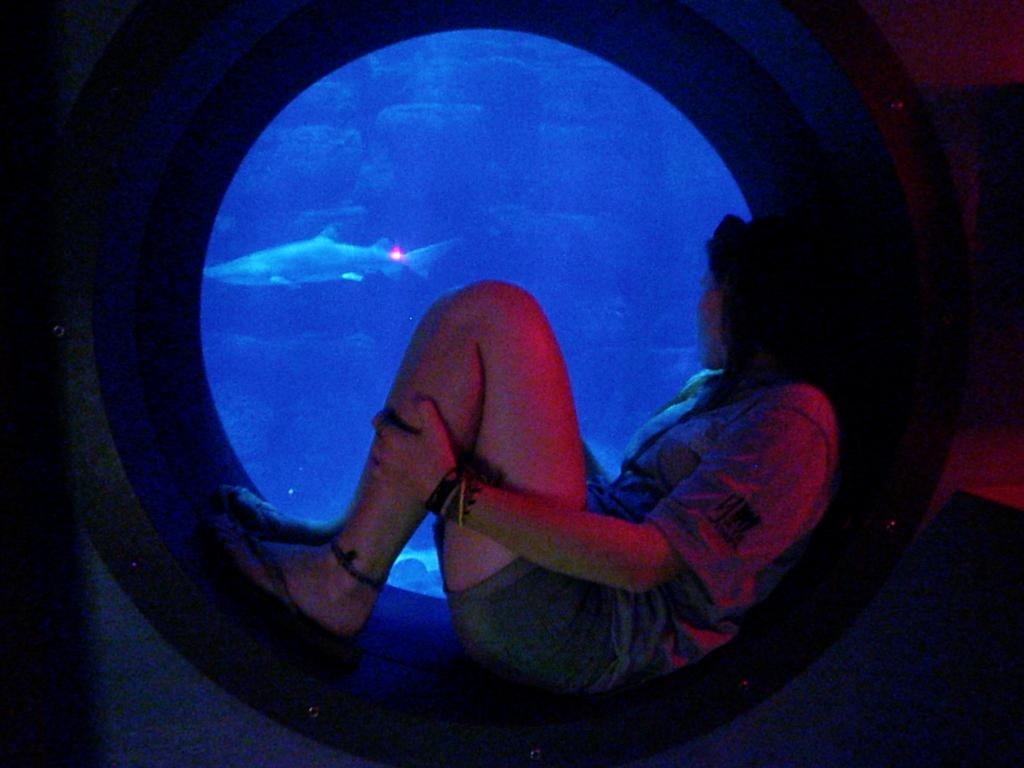What is the gender of the person in the image? The person in the image is a lady. What color is the shirt the lady person is wearing? The lady person is wearing a red shirt. What color are the boxers the lady person is wearing? The lady person is wearing green boxers. What is the lady person doing in the image? The lady person is sitting. What can be seen in the background of the image? There is a shark in the water in the background of the image. What color is the water in the image? The water is blue. What type of vase is on the table next to the lady person? There is no vase present in the image. Can you tell me what type of guitar the lady person is playing? The lady person is not playing a guitar in the image. 